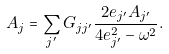<formula> <loc_0><loc_0><loc_500><loc_500>A _ { j } = \sum _ { j ^ { \prime } } G _ { j j ^ { \prime } } \frac { 2 e _ { j ^ { \prime } } A _ { j ^ { \prime } } } { 4 e _ { j ^ { \prime } } ^ { 2 } - \omega ^ { 2 } } .</formula> 